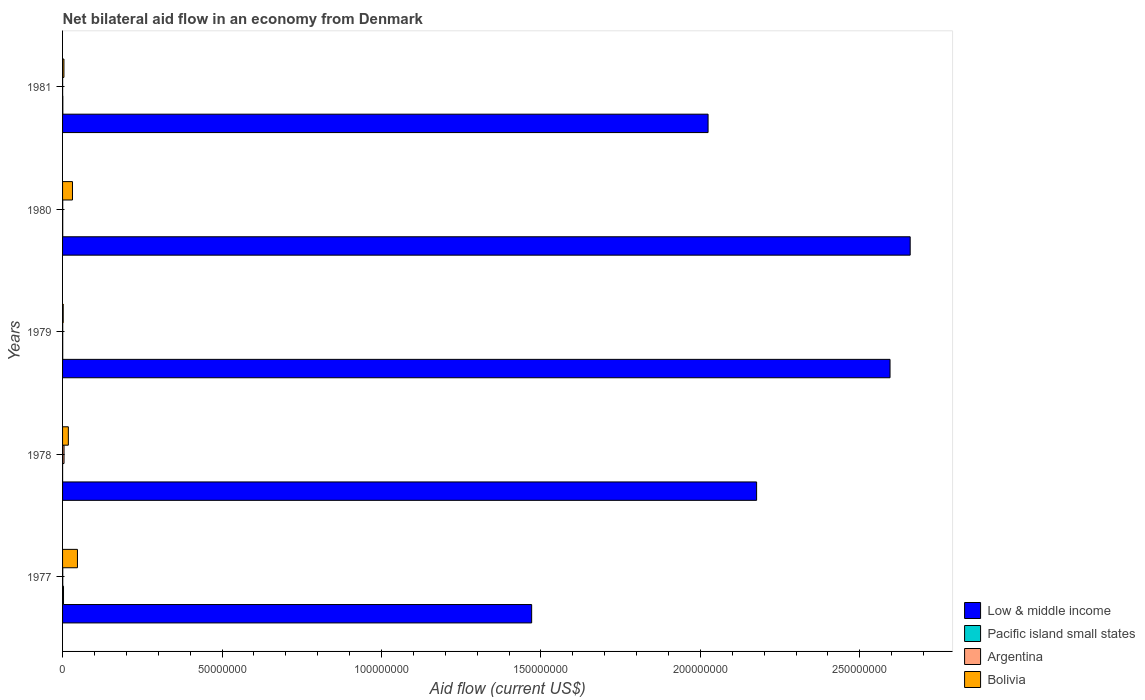How many bars are there on the 2nd tick from the top?
Offer a very short reply. 4. How many bars are there on the 3rd tick from the bottom?
Keep it short and to the point. 4. What is the label of the 4th group of bars from the top?
Provide a short and direct response. 1978. In how many cases, is the number of bars for a given year not equal to the number of legend labels?
Provide a succinct answer. 0. What is the net bilateral aid flow in Bolivia in 1980?
Ensure brevity in your answer.  3.11e+06. Across all years, what is the maximum net bilateral aid flow in Pacific island small states?
Provide a succinct answer. 3.00e+05. In which year was the net bilateral aid flow in Bolivia minimum?
Give a very brief answer. 1979. What is the total net bilateral aid flow in Pacific island small states in the graph?
Keep it short and to the point. 4.90e+05. What is the difference between the net bilateral aid flow in Bolivia in 1979 and the net bilateral aid flow in Low & middle income in 1980?
Your answer should be very brief. -2.66e+08. What is the average net bilateral aid flow in Low & middle income per year?
Your answer should be very brief. 2.18e+08. In the year 1977, what is the difference between the net bilateral aid flow in Bolivia and net bilateral aid flow in Low & middle income?
Give a very brief answer. -1.42e+08. What is the ratio of the net bilateral aid flow in Bolivia in 1979 to that in 1980?
Your response must be concise. 0.06. Is the net bilateral aid flow in Pacific island small states in 1977 less than that in 1978?
Give a very brief answer. No. What is the difference between the highest and the lowest net bilateral aid flow in Bolivia?
Give a very brief answer. 4.47e+06. Is it the case that in every year, the sum of the net bilateral aid flow in Bolivia and net bilateral aid flow in Pacific island small states is greater than the sum of net bilateral aid flow in Low & middle income and net bilateral aid flow in Argentina?
Provide a short and direct response. No. Is it the case that in every year, the sum of the net bilateral aid flow in Argentina and net bilateral aid flow in Low & middle income is greater than the net bilateral aid flow in Bolivia?
Your answer should be very brief. Yes. Are all the bars in the graph horizontal?
Make the answer very short. Yes. What is the difference between two consecutive major ticks on the X-axis?
Provide a succinct answer. 5.00e+07. Are the values on the major ticks of X-axis written in scientific E-notation?
Provide a short and direct response. No. Where does the legend appear in the graph?
Ensure brevity in your answer.  Bottom right. How are the legend labels stacked?
Your response must be concise. Vertical. What is the title of the graph?
Keep it short and to the point. Net bilateral aid flow in an economy from Denmark. What is the Aid flow (current US$) of Low & middle income in 1977?
Offer a terse response. 1.47e+08. What is the Aid flow (current US$) in Pacific island small states in 1977?
Your answer should be compact. 3.00e+05. What is the Aid flow (current US$) in Bolivia in 1977?
Provide a succinct answer. 4.67e+06. What is the Aid flow (current US$) in Low & middle income in 1978?
Offer a very short reply. 2.18e+08. What is the Aid flow (current US$) in Argentina in 1978?
Provide a succinct answer. 4.60e+05. What is the Aid flow (current US$) of Bolivia in 1978?
Your answer should be compact. 1.81e+06. What is the Aid flow (current US$) in Low & middle income in 1979?
Keep it short and to the point. 2.59e+08. What is the Aid flow (current US$) in Pacific island small states in 1979?
Your answer should be very brief. 5.00e+04. What is the Aid flow (current US$) of Low & middle income in 1980?
Offer a terse response. 2.66e+08. What is the Aid flow (current US$) in Pacific island small states in 1980?
Your response must be concise. 5.00e+04. What is the Aid flow (current US$) in Argentina in 1980?
Your answer should be very brief. 5.00e+04. What is the Aid flow (current US$) in Bolivia in 1980?
Your answer should be compact. 3.11e+06. What is the Aid flow (current US$) in Low & middle income in 1981?
Provide a succinct answer. 2.02e+08. What is the Aid flow (current US$) in Argentina in 1981?
Provide a short and direct response. 2.00e+04. What is the Aid flow (current US$) of Bolivia in 1981?
Keep it short and to the point. 4.30e+05. Across all years, what is the maximum Aid flow (current US$) of Low & middle income?
Offer a terse response. 2.66e+08. Across all years, what is the maximum Aid flow (current US$) in Bolivia?
Your answer should be very brief. 4.67e+06. Across all years, what is the minimum Aid flow (current US$) of Low & middle income?
Make the answer very short. 1.47e+08. Across all years, what is the minimum Aid flow (current US$) in Argentina?
Provide a short and direct response. 2.00e+04. Across all years, what is the minimum Aid flow (current US$) in Bolivia?
Your response must be concise. 2.00e+05. What is the total Aid flow (current US$) in Low & middle income in the graph?
Offer a very short reply. 1.09e+09. What is the total Aid flow (current US$) of Pacific island small states in the graph?
Offer a very short reply. 4.90e+05. What is the total Aid flow (current US$) in Argentina in the graph?
Your answer should be compact. 6.40e+05. What is the total Aid flow (current US$) in Bolivia in the graph?
Your answer should be very brief. 1.02e+07. What is the difference between the Aid flow (current US$) in Low & middle income in 1977 and that in 1978?
Offer a very short reply. -7.05e+07. What is the difference between the Aid flow (current US$) of Pacific island small states in 1977 and that in 1978?
Provide a succinct answer. 2.90e+05. What is the difference between the Aid flow (current US$) in Argentina in 1977 and that in 1978?
Offer a terse response. -4.00e+05. What is the difference between the Aid flow (current US$) of Bolivia in 1977 and that in 1978?
Give a very brief answer. 2.86e+06. What is the difference between the Aid flow (current US$) in Low & middle income in 1977 and that in 1979?
Ensure brevity in your answer.  -1.12e+08. What is the difference between the Aid flow (current US$) in Bolivia in 1977 and that in 1979?
Provide a succinct answer. 4.47e+06. What is the difference between the Aid flow (current US$) of Low & middle income in 1977 and that in 1980?
Offer a very short reply. -1.19e+08. What is the difference between the Aid flow (current US$) of Argentina in 1977 and that in 1980?
Your answer should be compact. 10000. What is the difference between the Aid flow (current US$) of Bolivia in 1977 and that in 1980?
Your answer should be compact. 1.56e+06. What is the difference between the Aid flow (current US$) of Low & middle income in 1977 and that in 1981?
Make the answer very short. -5.53e+07. What is the difference between the Aid flow (current US$) in Pacific island small states in 1977 and that in 1981?
Your answer should be very brief. 2.20e+05. What is the difference between the Aid flow (current US$) in Bolivia in 1977 and that in 1981?
Provide a short and direct response. 4.24e+06. What is the difference between the Aid flow (current US$) of Low & middle income in 1978 and that in 1979?
Provide a succinct answer. -4.18e+07. What is the difference between the Aid flow (current US$) of Pacific island small states in 1978 and that in 1979?
Your answer should be very brief. -4.00e+04. What is the difference between the Aid flow (current US$) in Argentina in 1978 and that in 1979?
Provide a succinct answer. 4.10e+05. What is the difference between the Aid flow (current US$) in Bolivia in 1978 and that in 1979?
Your response must be concise. 1.61e+06. What is the difference between the Aid flow (current US$) in Low & middle income in 1978 and that in 1980?
Offer a very short reply. -4.82e+07. What is the difference between the Aid flow (current US$) of Pacific island small states in 1978 and that in 1980?
Provide a short and direct response. -4.00e+04. What is the difference between the Aid flow (current US$) in Argentina in 1978 and that in 1980?
Offer a terse response. 4.10e+05. What is the difference between the Aid flow (current US$) in Bolivia in 1978 and that in 1980?
Make the answer very short. -1.30e+06. What is the difference between the Aid flow (current US$) in Low & middle income in 1978 and that in 1981?
Provide a succinct answer. 1.52e+07. What is the difference between the Aid flow (current US$) of Pacific island small states in 1978 and that in 1981?
Provide a succinct answer. -7.00e+04. What is the difference between the Aid flow (current US$) in Argentina in 1978 and that in 1981?
Keep it short and to the point. 4.40e+05. What is the difference between the Aid flow (current US$) in Bolivia in 1978 and that in 1981?
Offer a terse response. 1.38e+06. What is the difference between the Aid flow (current US$) in Low & middle income in 1979 and that in 1980?
Your answer should be compact. -6.32e+06. What is the difference between the Aid flow (current US$) in Pacific island small states in 1979 and that in 1980?
Provide a short and direct response. 0. What is the difference between the Aid flow (current US$) in Bolivia in 1979 and that in 1980?
Your answer should be very brief. -2.91e+06. What is the difference between the Aid flow (current US$) in Low & middle income in 1979 and that in 1981?
Your answer should be very brief. 5.71e+07. What is the difference between the Aid flow (current US$) of Argentina in 1979 and that in 1981?
Provide a succinct answer. 3.00e+04. What is the difference between the Aid flow (current US$) in Low & middle income in 1980 and that in 1981?
Provide a short and direct response. 6.34e+07. What is the difference between the Aid flow (current US$) of Bolivia in 1980 and that in 1981?
Your response must be concise. 2.68e+06. What is the difference between the Aid flow (current US$) in Low & middle income in 1977 and the Aid flow (current US$) in Pacific island small states in 1978?
Give a very brief answer. 1.47e+08. What is the difference between the Aid flow (current US$) of Low & middle income in 1977 and the Aid flow (current US$) of Argentina in 1978?
Keep it short and to the point. 1.47e+08. What is the difference between the Aid flow (current US$) of Low & middle income in 1977 and the Aid flow (current US$) of Bolivia in 1978?
Your response must be concise. 1.45e+08. What is the difference between the Aid flow (current US$) of Pacific island small states in 1977 and the Aid flow (current US$) of Bolivia in 1978?
Your answer should be compact. -1.51e+06. What is the difference between the Aid flow (current US$) of Argentina in 1977 and the Aid flow (current US$) of Bolivia in 1978?
Provide a short and direct response. -1.75e+06. What is the difference between the Aid flow (current US$) of Low & middle income in 1977 and the Aid flow (current US$) of Pacific island small states in 1979?
Your answer should be very brief. 1.47e+08. What is the difference between the Aid flow (current US$) of Low & middle income in 1977 and the Aid flow (current US$) of Argentina in 1979?
Your answer should be very brief. 1.47e+08. What is the difference between the Aid flow (current US$) in Low & middle income in 1977 and the Aid flow (current US$) in Bolivia in 1979?
Give a very brief answer. 1.47e+08. What is the difference between the Aid flow (current US$) of Pacific island small states in 1977 and the Aid flow (current US$) of Argentina in 1979?
Your answer should be very brief. 2.50e+05. What is the difference between the Aid flow (current US$) in Pacific island small states in 1977 and the Aid flow (current US$) in Bolivia in 1979?
Keep it short and to the point. 1.00e+05. What is the difference between the Aid flow (current US$) in Low & middle income in 1977 and the Aid flow (current US$) in Pacific island small states in 1980?
Ensure brevity in your answer.  1.47e+08. What is the difference between the Aid flow (current US$) of Low & middle income in 1977 and the Aid flow (current US$) of Argentina in 1980?
Provide a succinct answer. 1.47e+08. What is the difference between the Aid flow (current US$) of Low & middle income in 1977 and the Aid flow (current US$) of Bolivia in 1980?
Your response must be concise. 1.44e+08. What is the difference between the Aid flow (current US$) in Pacific island small states in 1977 and the Aid flow (current US$) in Bolivia in 1980?
Your response must be concise. -2.81e+06. What is the difference between the Aid flow (current US$) in Argentina in 1977 and the Aid flow (current US$) in Bolivia in 1980?
Provide a succinct answer. -3.05e+06. What is the difference between the Aid flow (current US$) in Low & middle income in 1977 and the Aid flow (current US$) in Pacific island small states in 1981?
Keep it short and to the point. 1.47e+08. What is the difference between the Aid flow (current US$) in Low & middle income in 1977 and the Aid flow (current US$) in Argentina in 1981?
Ensure brevity in your answer.  1.47e+08. What is the difference between the Aid flow (current US$) of Low & middle income in 1977 and the Aid flow (current US$) of Bolivia in 1981?
Your response must be concise. 1.47e+08. What is the difference between the Aid flow (current US$) of Pacific island small states in 1977 and the Aid flow (current US$) of Argentina in 1981?
Offer a terse response. 2.80e+05. What is the difference between the Aid flow (current US$) in Argentina in 1977 and the Aid flow (current US$) in Bolivia in 1981?
Offer a very short reply. -3.70e+05. What is the difference between the Aid flow (current US$) of Low & middle income in 1978 and the Aid flow (current US$) of Pacific island small states in 1979?
Offer a very short reply. 2.18e+08. What is the difference between the Aid flow (current US$) in Low & middle income in 1978 and the Aid flow (current US$) in Argentina in 1979?
Provide a short and direct response. 2.18e+08. What is the difference between the Aid flow (current US$) of Low & middle income in 1978 and the Aid flow (current US$) of Bolivia in 1979?
Your answer should be compact. 2.17e+08. What is the difference between the Aid flow (current US$) in Pacific island small states in 1978 and the Aid flow (current US$) in Argentina in 1979?
Ensure brevity in your answer.  -4.00e+04. What is the difference between the Aid flow (current US$) of Pacific island small states in 1978 and the Aid flow (current US$) of Bolivia in 1979?
Ensure brevity in your answer.  -1.90e+05. What is the difference between the Aid flow (current US$) in Argentina in 1978 and the Aid flow (current US$) in Bolivia in 1979?
Offer a very short reply. 2.60e+05. What is the difference between the Aid flow (current US$) of Low & middle income in 1978 and the Aid flow (current US$) of Pacific island small states in 1980?
Keep it short and to the point. 2.18e+08. What is the difference between the Aid flow (current US$) of Low & middle income in 1978 and the Aid flow (current US$) of Argentina in 1980?
Offer a terse response. 2.18e+08. What is the difference between the Aid flow (current US$) in Low & middle income in 1978 and the Aid flow (current US$) in Bolivia in 1980?
Keep it short and to the point. 2.15e+08. What is the difference between the Aid flow (current US$) in Pacific island small states in 1978 and the Aid flow (current US$) in Bolivia in 1980?
Keep it short and to the point. -3.10e+06. What is the difference between the Aid flow (current US$) in Argentina in 1978 and the Aid flow (current US$) in Bolivia in 1980?
Give a very brief answer. -2.65e+06. What is the difference between the Aid flow (current US$) of Low & middle income in 1978 and the Aid flow (current US$) of Pacific island small states in 1981?
Your answer should be very brief. 2.18e+08. What is the difference between the Aid flow (current US$) of Low & middle income in 1978 and the Aid flow (current US$) of Argentina in 1981?
Offer a terse response. 2.18e+08. What is the difference between the Aid flow (current US$) of Low & middle income in 1978 and the Aid flow (current US$) of Bolivia in 1981?
Keep it short and to the point. 2.17e+08. What is the difference between the Aid flow (current US$) in Pacific island small states in 1978 and the Aid flow (current US$) in Argentina in 1981?
Offer a very short reply. -10000. What is the difference between the Aid flow (current US$) in Pacific island small states in 1978 and the Aid flow (current US$) in Bolivia in 1981?
Your answer should be compact. -4.20e+05. What is the difference between the Aid flow (current US$) in Argentina in 1978 and the Aid flow (current US$) in Bolivia in 1981?
Ensure brevity in your answer.  3.00e+04. What is the difference between the Aid flow (current US$) of Low & middle income in 1979 and the Aid flow (current US$) of Pacific island small states in 1980?
Ensure brevity in your answer.  2.59e+08. What is the difference between the Aid flow (current US$) in Low & middle income in 1979 and the Aid flow (current US$) in Argentina in 1980?
Offer a terse response. 2.59e+08. What is the difference between the Aid flow (current US$) of Low & middle income in 1979 and the Aid flow (current US$) of Bolivia in 1980?
Your response must be concise. 2.56e+08. What is the difference between the Aid flow (current US$) of Pacific island small states in 1979 and the Aid flow (current US$) of Argentina in 1980?
Your response must be concise. 0. What is the difference between the Aid flow (current US$) in Pacific island small states in 1979 and the Aid flow (current US$) in Bolivia in 1980?
Make the answer very short. -3.06e+06. What is the difference between the Aid flow (current US$) of Argentina in 1979 and the Aid flow (current US$) of Bolivia in 1980?
Offer a very short reply. -3.06e+06. What is the difference between the Aid flow (current US$) of Low & middle income in 1979 and the Aid flow (current US$) of Pacific island small states in 1981?
Offer a very short reply. 2.59e+08. What is the difference between the Aid flow (current US$) of Low & middle income in 1979 and the Aid flow (current US$) of Argentina in 1981?
Your answer should be very brief. 2.59e+08. What is the difference between the Aid flow (current US$) of Low & middle income in 1979 and the Aid flow (current US$) of Bolivia in 1981?
Offer a very short reply. 2.59e+08. What is the difference between the Aid flow (current US$) of Pacific island small states in 1979 and the Aid flow (current US$) of Bolivia in 1981?
Give a very brief answer. -3.80e+05. What is the difference between the Aid flow (current US$) of Argentina in 1979 and the Aid flow (current US$) of Bolivia in 1981?
Offer a terse response. -3.80e+05. What is the difference between the Aid flow (current US$) in Low & middle income in 1980 and the Aid flow (current US$) in Pacific island small states in 1981?
Give a very brief answer. 2.66e+08. What is the difference between the Aid flow (current US$) in Low & middle income in 1980 and the Aid flow (current US$) in Argentina in 1981?
Make the answer very short. 2.66e+08. What is the difference between the Aid flow (current US$) in Low & middle income in 1980 and the Aid flow (current US$) in Bolivia in 1981?
Provide a succinct answer. 2.65e+08. What is the difference between the Aid flow (current US$) of Pacific island small states in 1980 and the Aid flow (current US$) of Argentina in 1981?
Keep it short and to the point. 3.00e+04. What is the difference between the Aid flow (current US$) of Pacific island small states in 1980 and the Aid flow (current US$) of Bolivia in 1981?
Provide a short and direct response. -3.80e+05. What is the difference between the Aid flow (current US$) in Argentina in 1980 and the Aid flow (current US$) in Bolivia in 1981?
Keep it short and to the point. -3.80e+05. What is the average Aid flow (current US$) of Low & middle income per year?
Your answer should be very brief. 2.18e+08. What is the average Aid flow (current US$) in Pacific island small states per year?
Offer a terse response. 9.80e+04. What is the average Aid flow (current US$) in Argentina per year?
Offer a very short reply. 1.28e+05. What is the average Aid flow (current US$) of Bolivia per year?
Offer a terse response. 2.04e+06. In the year 1977, what is the difference between the Aid flow (current US$) in Low & middle income and Aid flow (current US$) in Pacific island small states?
Make the answer very short. 1.47e+08. In the year 1977, what is the difference between the Aid flow (current US$) in Low & middle income and Aid flow (current US$) in Argentina?
Offer a very short reply. 1.47e+08. In the year 1977, what is the difference between the Aid flow (current US$) of Low & middle income and Aid flow (current US$) of Bolivia?
Make the answer very short. 1.42e+08. In the year 1977, what is the difference between the Aid flow (current US$) of Pacific island small states and Aid flow (current US$) of Bolivia?
Offer a terse response. -4.37e+06. In the year 1977, what is the difference between the Aid flow (current US$) of Argentina and Aid flow (current US$) of Bolivia?
Provide a short and direct response. -4.61e+06. In the year 1978, what is the difference between the Aid flow (current US$) of Low & middle income and Aid flow (current US$) of Pacific island small states?
Give a very brief answer. 2.18e+08. In the year 1978, what is the difference between the Aid flow (current US$) of Low & middle income and Aid flow (current US$) of Argentina?
Your answer should be very brief. 2.17e+08. In the year 1978, what is the difference between the Aid flow (current US$) in Low & middle income and Aid flow (current US$) in Bolivia?
Offer a terse response. 2.16e+08. In the year 1978, what is the difference between the Aid flow (current US$) in Pacific island small states and Aid flow (current US$) in Argentina?
Ensure brevity in your answer.  -4.50e+05. In the year 1978, what is the difference between the Aid flow (current US$) in Pacific island small states and Aid flow (current US$) in Bolivia?
Your response must be concise. -1.80e+06. In the year 1978, what is the difference between the Aid flow (current US$) of Argentina and Aid flow (current US$) of Bolivia?
Ensure brevity in your answer.  -1.35e+06. In the year 1979, what is the difference between the Aid flow (current US$) of Low & middle income and Aid flow (current US$) of Pacific island small states?
Offer a very short reply. 2.59e+08. In the year 1979, what is the difference between the Aid flow (current US$) in Low & middle income and Aid flow (current US$) in Argentina?
Offer a very short reply. 2.59e+08. In the year 1979, what is the difference between the Aid flow (current US$) in Low & middle income and Aid flow (current US$) in Bolivia?
Provide a short and direct response. 2.59e+08. In the year 1979, what is the difference between the Aid flow (current US$) of Pacific island small states and Aid flow (current US$) of Argentina?
Offer a very short reply. 0. In the year 1979, what is the difference between the Aid flow (current US$) of Pacific island small states and Aid flow (current US$) of Bolivia?
Offer a terse response. -1.50e+05. In the year 1979, what is the difference between the Aid flow (current US$) in Argentina and Aid flow (current US$) in Bolivia?
Ensure brevity in your answer.  -1.50e+05. In the year 1980, what is the difference between the Aid flow (current US$) in Low & middle income and Aid flow (current US$) in Pacific island small states?
Your answer should be compact. 2.66e+08. In the year 1980, what is the difference between the Aid flow (current US$) of Low & middle income and Aid flow (current US$) of Argentina?
Offer a very short reply. 2.66e+08. In the year 1980, what is the difference between the Aid flow (current US$) of Low & middle income and Aid flow (current US$) of Bolivia?
Provide a succinct answer. 2.63e+08. In the year 1980, what is the difference between the Aid flow (current US$) of Pacific island small states and Aid flow (current US$) of Argentina?
Offer a terse response. 0. In the year 1980, what is the difference between the Aid flow (current US$) of Pacific island small states and Aid flow (current US$) of Bolivia?
Your answer should be compact. -3.06e+06. In the year 1980, what is the difference between the Aid flow (current US$) in Argentina and Aid flow (current US$) in Bolivia?
Keep it short and to the point. -3.06e+06. In the year 1981, what is the difference between the Aid flow (current US$) of Low & middle income and Aid flow (current US$) of Pacific island small states?
Keep it short and to the point. 2.02e+08. In the year 1981, what is the difference between the Aid flow (current US$) in Low & middle income and Aid flow (current US$) in Argentina?
Your response must be concise. 2.02e+08. In the year 1981, what is the difference between the Aid flow (current US$) of Low & middle income and Aid flow (current US$) of Bolivia?
Your answer should be compact. 2.02e+08. In the year 1981, what is the difference between the Aid flow (current US$) in Pacific island small states and Aid flow (current US$) in Argentina?
Offer a very short reply. 6.00e+04. In the year 1981, what is the difference between the Aid flow (current US$) of Pacific island small states and Aid flow (current US$) of Bolivia?
Your response must be concise. -3.50e+05. In the year 1981, what is the difference between the Aid flow (current US$) of Argentina and Aid flow (current US$) of Bolivia?
Ensure brevity in your answer.  -4.10e+05. What is the ratio of the Aid flow (current US$) in Low & middle income in 1977 to that in 1978?
Offer a very short reply. 0.68. What is the ratio of the Aid flow (current US$) of Argentina in 1977 to that in 1978?
Keep it short and to the point. 0.13. What is the ratio of the Aid flow (current US$) of Bolivia in 1977 to that in 1978?
Make the answer very short. 2.58. What is the ratio of the Aid flow (current US$) of Low & middle income in 1977 to that in 1979?
Offer a terse response. 0.57. What is the ratio of the Aid flow (current US$) in Argentina in 1977 to that in 1979?
Your answer should be very brief. 1.2. What is the ratio of the Aid flow (current US$) of Bolivia in 1977 to that in 1979?
Provide a short and direct response. 23.35. What is the ratio of the Aid flow (current US$) of Low & middle income in 1977 to that in 1980?
Your response must be concise. 0.55. What is the ratio of the Aid flow (current US$) of Pacific island small states in 1977 to that in 1980?
Your response must be concise. 6. What is the ratio of the Aid flow (current US$) of Argentina in 1977 to that in 1980?
Your answer should be very brief. 1.2. What is the ratio of the Aid flow (current US$) of Bolivia in 1977 to that in 1980?
Your answer should be compact. 1.5. What is the ratio of the Aid flow (current US$) in Low & middle income in 1977 to that in 1981?
Make the answer very short. 0.73. What is the ratio of the Aid flow (current US$) in Pacific island small states in 1977 to that in 1981?
Offer a very short reply. 3.75. What is the ratio of the Aid flow (current US$) in Argentina in 1977 to that in 1981?
Offer a terse response. 3. What is the ratio of the Aid flow (current US$) of Bolivia in 1977 to that in 1981?
Keep it short and to the point. 10.86. What is the ratio of the Aid flow (current US$) of Low & middle income in 1978 to that in 1979?
Provide a short and direct response. 0.84. What is the ratio of the Aid flow (current US$) of Bolivia in 1978 to that in 1979?
Offer a terse response. 9.05. What is the ratio of the Aid flow (current US$) of Low & middle income in 1978 to that in 1980?
Make the answer very short. 0.82. What is the ratio of the Aid flow (current US$) of Pacific island small states in 1978 to that in 1980?
Provide a succinct answer. 0.2. What is the ratio of the Aid flow (current US$) of Argentina in 1978 to that in 1980?
Your response must be concise. 9.2. What is the ratio of the Aid flow (current US$) in Bolivia in 1978 to that in 1980?
Ensure brevity in your answer.  0.58. What is the ratio of the Aid flow (current US$) of Low & middle income in 1978 to that in 1981?
Ensure brevity in your answer.  1.08. What is the ratio of the Aid flow (current US$) of Bolivia in 1978 to that in 1981?
Provide a short and direct response. 4.21. What is the ratio of the Aid flow (current US$) of Low & middle income in 1979 to that in 1980?
Your answer should be very brief. 0.98. What is the ratio of the Aid flow (current US$) in Argentina in 1979 to that in 1980?
Your answer should be compact. 1. What is the ratio of the Aid flow (current US$) in Bolivia in 1979 to that in 1980?
Your answer should be compact. 0.06. What is the ratio of the Aid flow (current US$) in Low & middle income in 1979 to that in 1981?
Your answer should be very brief. 1.28. What is the ratio of the Aid flow (current US$) in Bolivia in 1979 to that in 1981?
Make the answer very short. 0.47. What is the ratio of the Aid flow (current US$) in Low & middle income in 1980 to that in 1981?
Give a very brief answer. 1.31. What is the ratio of the Aid flow (current US$) of Pacific island small states in 1980 to that in 1981?
Provide a succinct answer. 0.62. What is the ratio of the Aid flow (current US$) of Argentina in 1980 to that in 1981?
Keep it short and to the point. 2.5. What is the ratio of the Aid flow (current US$) of Bolivia in 1980 to that in 1981?
Make the answer very short. 7.23. What is the difference between the highest and the second highest Aid flow (current US$) of Low & middle income?
Provide a short and direct response. 6.32e+06. What is the difference between the highest and the second highest Aid flow (current US$) in Pacific island small states?
Provide a short and direct response. 2.20e+05. What is the difference between the highest and the second highest Aid flow (current US$) in Bolivia?
Ensure brevity in your answer.  1.56e+06. What is the difference between the highest and the lowest Aid flow (current US$) of Low & middle income?
Your response must be concise. 1.19e+08. What is the difference between the highest and the lowest Aid flow (current US$) in Argentina?
Your answer should be very brief. 4.40e+05. What is the difference between the highest and the lowest Aid flow (current US$) in Bolivia?
Offer a terse response. 4.47e+06. 